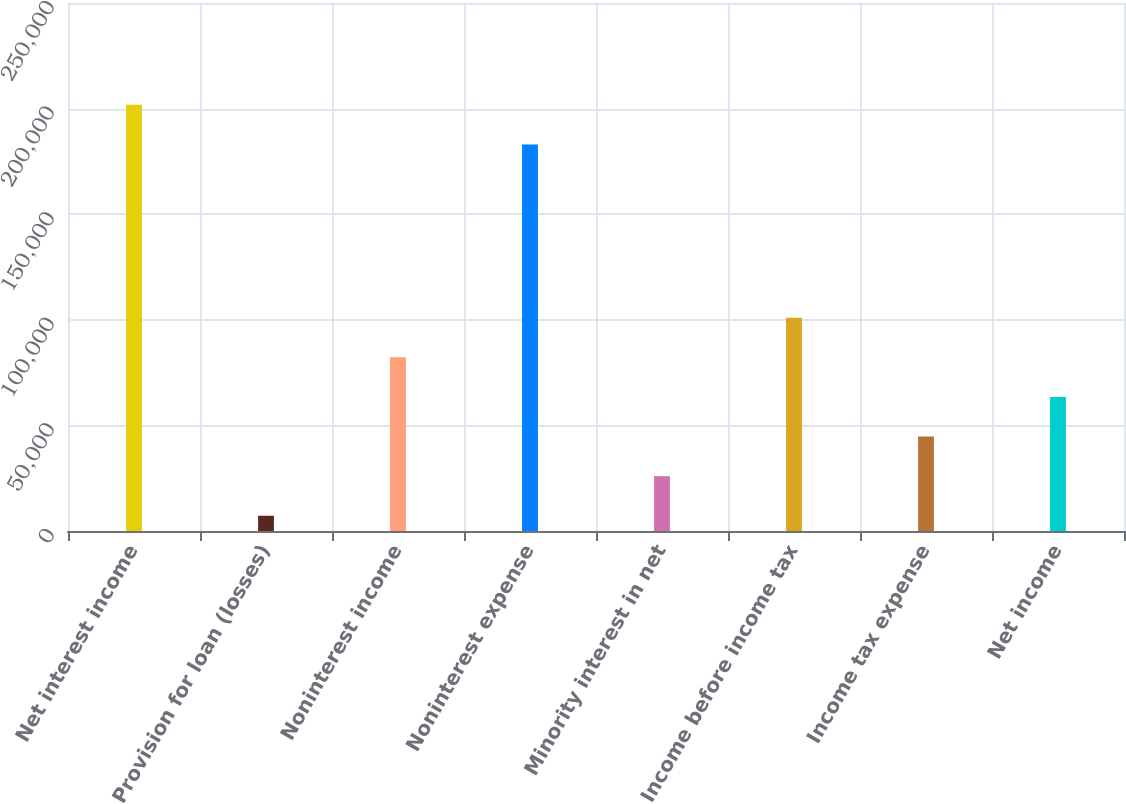Convert chart to OTSL. <chart><loc_0><loc_0><loc_500><loc_500><bar_chart><fcel>Net interest income<fcel>Provision for loan (losses)<fcel>Noninterest income<fcel>Noninterest expense<fcel>Minority interest in net<fcel>Income before income tax<fcel>Income tax expense<fcel>Net income<nl><fcel>201785<fcel>7220<fcel>82215.2<fcel>183036<fcel>25968.8<fcel>100964<fcel>44717.6<fcel>63466.4<nl></chart> 